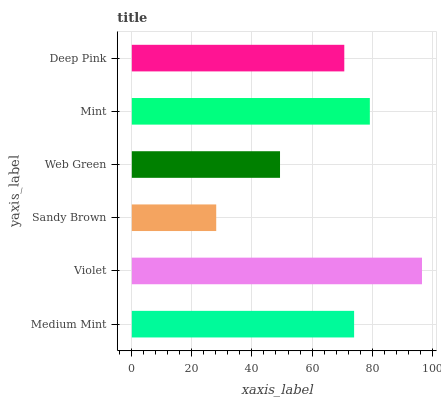Is Sandy Brown the minimum?
Answer yes or no. Yes. Is Violet the maximum?
Answer yes or no. Yes. Is Violet the minimum?
Answer yes or no. No. Is Sandy Brown the maximum?
Answer yes or no. No. Is Violet greater than Sandy Brown?
Answer yes or no. Yes. Is Sandy Brown less than Violet?
Answer yes or no. Yes. Is Sandy Brown greater than Violet?
Answer yes or no. No. Is Violet less than Sandy Brown?
Answer yes or no. No. Is Medium Mint the high median?
Answer yes or no. Yes. Is Deep Pink the low median?
Answer yes or no. Yes. Is Sandy Brown the high median?
Answer yes or no. No. Is Sandy Brown the low median?
Answer yes or no. No. 